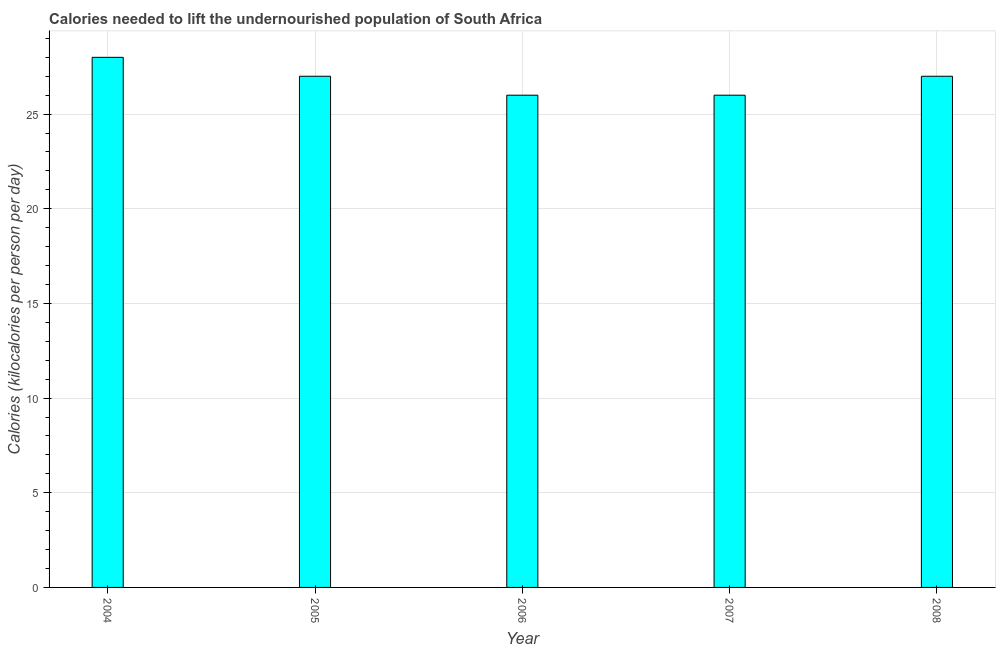Does the graph contain grids?
Give a very brief answer. Yes. What is the title of the graph?
Your answer should be very brief. Calories needed to lift the undernourished population of South Africa. What is the label or title of the X-axis?
Give a very brief answer. Year. What is the label or title of the Y-axis?
Give a very brief answer. Calories (kilocalories per person per day). What is the depth of food deficit in 2005?
Make the answer very short. 27. In which year was the depth of food deficit minimum?
Keep it short and to the point. 2006. What is the sum of the depth of food deficit?
Your response must be concise. 134. What is the median depth of food deficit?
Your answer should be very brief. 27. In how many years, is the depth of food deficit greater than 22 kilocalories?
Make the answer very short. 5. Do a majority of the years between 2008 and 2005 (inclusive) have depth of food deficit greater than 25 kilocalories?
Offer a very short reply. Yes. What is the ratio of the depth of food deficit in 2006 to that in 2007?
Offer a terse response. 1. Is the depth of food deficit in 2006 less than that in 2007?
Provide a short and direct response. No. What is the difference between the highest and the second highest depth of food deficit?
Keep it short and to the point. 1. What is the difference between the highest and the lowest depth of food deficit?
Keep it short and to the point. 2. In how many years, is the depth of food deficit greater than the average depth of food deficit taken over all years?
Provide a short and direct response. 3. What is the Calories (kilocalories per person per day) of 2005?
Provide a succinct answer. 27. What is the Calories (kilocalories per person per day) in 2007?
Make the answer very short. 26. What is the difference between the Calories (kilocalories per person per day) in 2004 and 2007?
Give a very brief answer. 2. What is the difference between the Calories (kilocalories per person per day) in 2005 and 2006?
Provide a succinct answer. 1. What is the difference between the Calories (kilocalories per person per day) in 2005 and 2007?
Make the answer very short. 1. What is the difference between the Calories (kilocalories per person per day) in 2005 and 2008?
Your answer should be very brief. 0. What is the difference between the Calories (kilocalories per person per day) in 2006 and 2007?
Ensure brevity in your answer.  0. What is the ratio of the Calories (kilocalories per person per day) in 2004 to that in 2005?
Provide a succinct answer. 1.04. What is the ratio of the Calories (kilocalories per person per day) in 2004 to that in 2006?
Your answer should be very brief. 1.08. What is the ratio of the Calories (kilocalories per person per day) in 2004 to that in 2007?
Your answer should be very brief. 1.08. What is the ratio of the Calories (kilocalories per person per day) in 2004 to that in 2008?
Your answer should be very brief. 1.04. What is the ratio of the Calories (kilocalories per person per day) in 2005 to that in 2006?
Provide a succinct answer. 1.04. What is the ratio of the Calories (kilocalories per person per day) in 2005 to that in 2007?
Offer a very short reply. 1.04. What is the ratio of the Calories (kilocalories per person per day) in 2005 to that in 2008?
Offer a terse response. 1. What is the ratio of the Calories (kilocalories per person per day) in 2007 to that in 2008?
Your response must be concise. 0.96. 